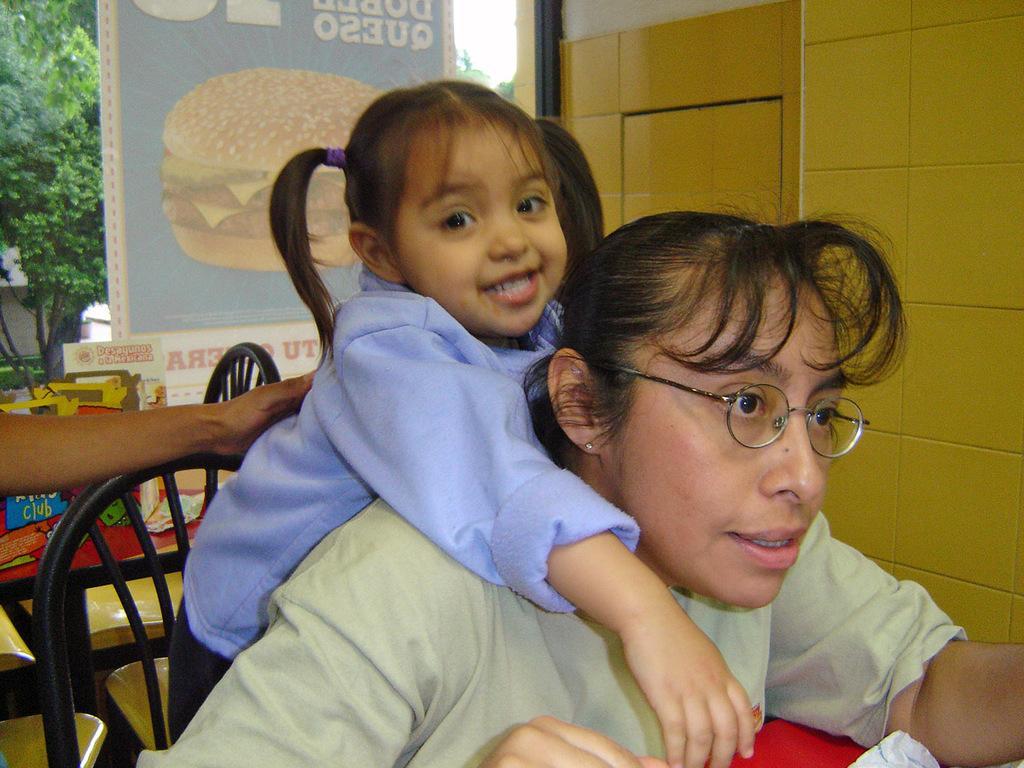Please provide a concise description of this image. In this picture there is a woman who is wearing spectacles looking at something. Behind her there is a girl who is standing and smiling and this woman sat on this chair, black chair. It seems like a restaurant or something, tables present and it is like some bun advertisement. It is a glass, behind it there is a tree and this seems like hand of some person. 